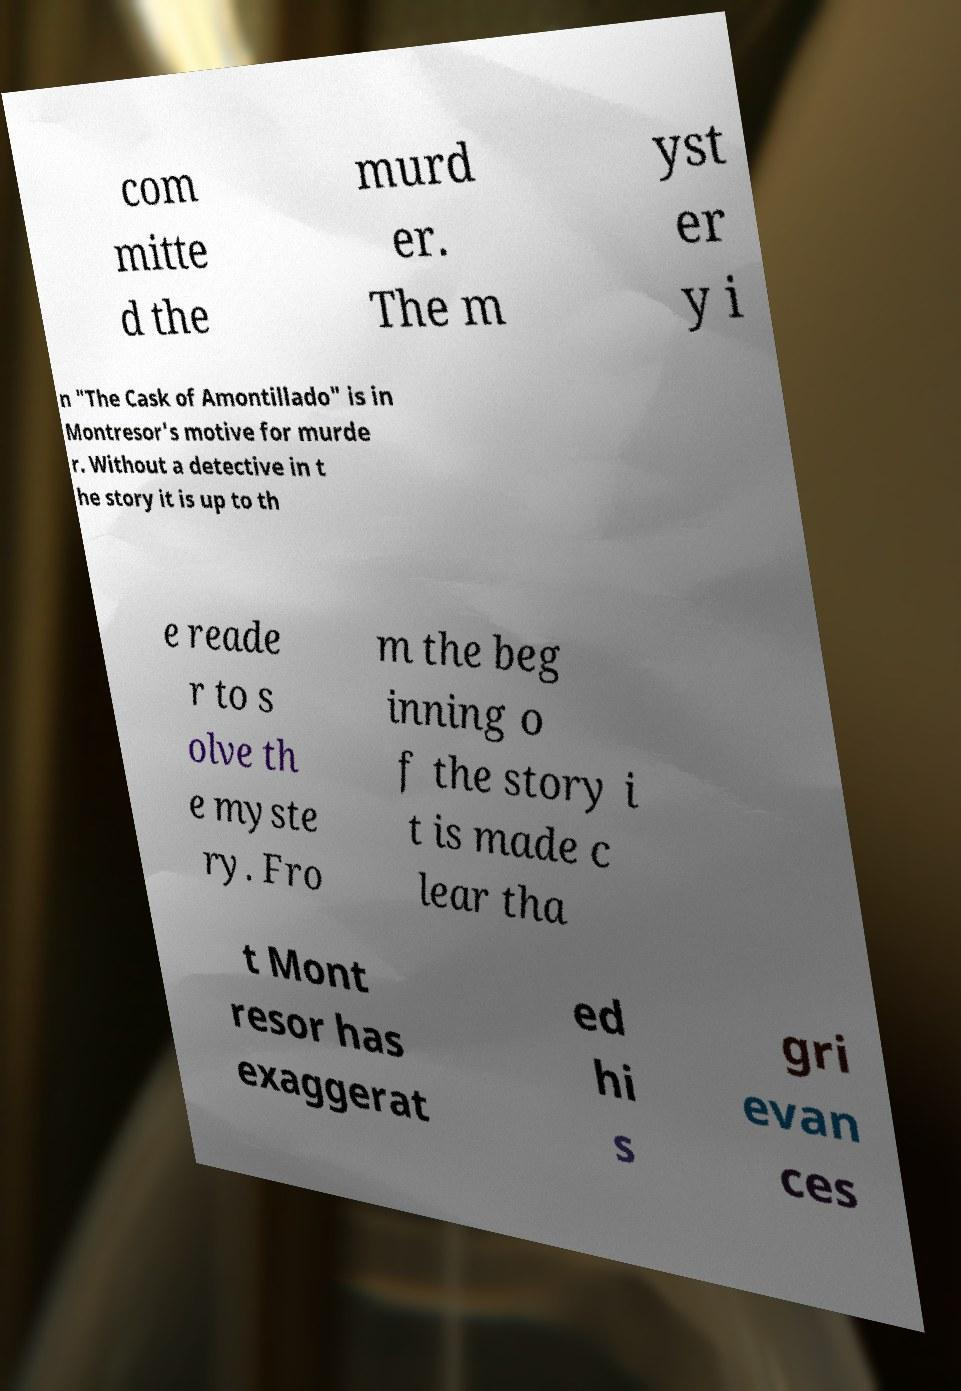Please identify and transcribe the text found in this image. com mitte d the murd er. The m yst er y i n "The Cask of Amontillado" is in Montresor's motive for murde r. Without a detective in t he story it is up to th e reade r to s olve th e myste ry. Fro m the beg inning o f the story i t is made c lear tha t Mont resor has exaggerat ed hi s gri evan ces 